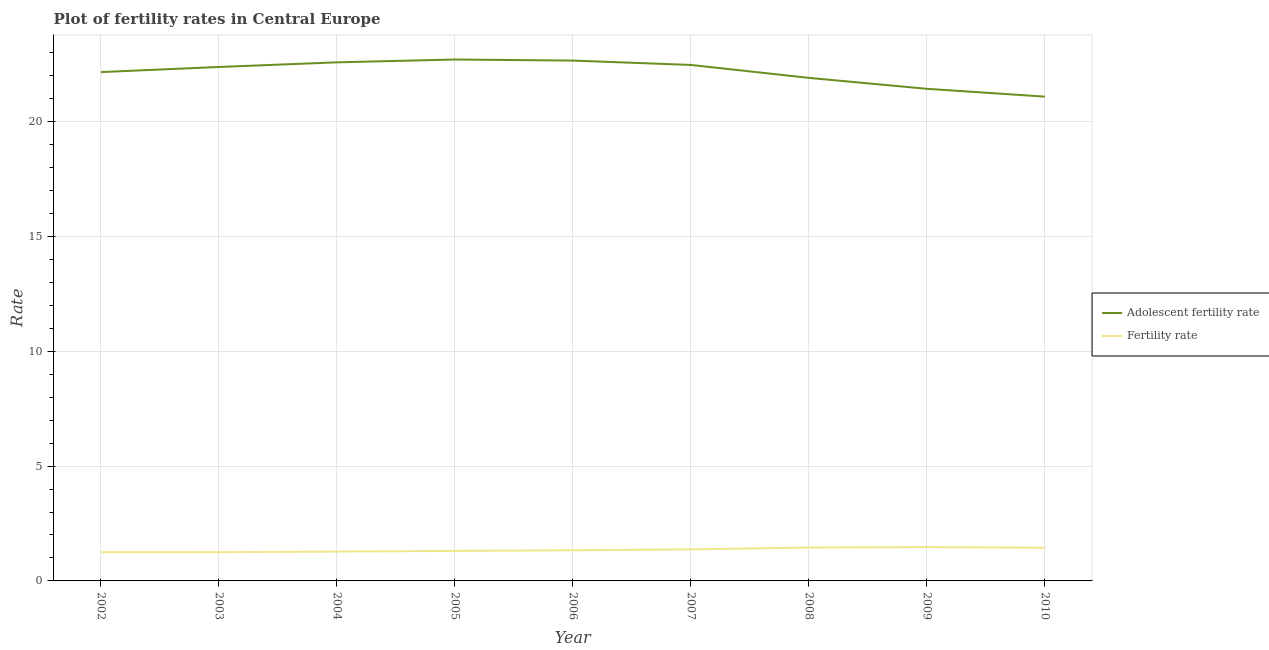How many different coloured lines are there?
Keep it short and to the point. 2. Does the line corresponding to fertility rate intersect with the line corresponding to adolescent fertility rate?
Give a very brief answer. No. What is the adolescent fertility rate in 2010?
Give a very brief answer. 21.09. Across all years, what is the maximum fertility rate?
Your answer should be very brief. 1.47. Across all years, what is the minimum fertility rate?
Provide a succinct answer. 1.25. In which year was the fertility rate maximum?
Give a very brief answer. 2009. In which year was the adolescent fertility rate minimum?
Your answer should be very brief. 2010. What is the total fertility rate in the graph?
Ensure brevity in your answer.  12.17. What is the difference between the fertility rate in 2004 and that in 2006?
Your answer should be compact. -0.06. What is the difference between the fertility rate in 2008 and the adolescent fertility rate in 2009?
Provide a short and direct response. -19.98. What is the average adolescent fertility rate per year?
Make the answer very short. 22.15. In the year 2009, what is the difference between the adolescent fertility rate and fertility rate?
Give a very brief answer. 19.96. What is the ratio of the adolescent fertility rate in 2003 to that in 2010?
Your answer should be compact. 1.06. What is the difference between the highest and the second highest adolescent fertility rate?
Your response must be concise. 0.05. What is the difference between the highest and the lowest adolescent fertility rate?
Offer a very short reply. 1.62. Is the adolescent fertility rate strictly less than the fertility rate over the years?
Keep it short and to the point. No. How many years are there in the graph?
Offer a very short reply. 9. What is the difference between two consecutive major ticks on the Y-axis?
Offer a terse response. 5. Are the values on the major ticks of Y-axis written in scientific E-notation?
Offer a very short reply. No. Does the graph contain any zero values?
Provide a succinct answer. No. Does the graph contain grids?
Your answer should be very brief. Yes. How many legend labels are there?
Your answer should be compact. 2. How are the legend labels stacked?
Provide a short and direct response. Vertical. What is the title of the graph?
Offer a terse response. Plot of fertility rates in Central Europe. What is the label or title of the X-axis?
Provide a succinct answer. Year. What is the label or title of the Y-axis?
Make the answer very short. Rate. What is the Rate of Adolescent fertility rate in 2002?
Provide a short and direct response. 22.16. What is the Rate of Fertility rate in 2002?
Your response must be concise. 1.25. What is the Rate in Adolescent fertility rate in 2003?
Provide a succinct answer. 22.38. What is the Rate in Fertility rate in 2003?
Make the answer very short. 1.25. What is the Rate in Adolescent fertility rate in 2004?
Ensure brevity in your answer.  22.58. What is the Rate of Fertility rate in 2004?
Keep it short and to the point. 1.28. What is the Rate of Adolescent fertility rate in 2005?
Keep it short and to the point. 22.7. What is the Rate of Fertility rate in 2005?
Provide a short and direct response. 1.31. What is the Rate of Adolescent fertility rate in 2006?
Your answer should be very brief. 22.66. What is the Rate of Fertility rate in 2006?
Offer a terse response. 1.33. What is the Rate of Adolescent fertility rate in 2007?
Give a very brief answer. 22.47. What is the Rate in Fertility rate in 2007?
Make the answer very short. 1.38. What is the Rate in Adolescent fertility rate in 2008?
Provide a short and direct response. 21.9. What is the Rate of Fertility rate in 2008?
Make the answer very short. 1.45. What is the Rate in Adolescent fertility rate in 2009?
Keep it short and to the point. 21.43. What is the Rate of Fertility rate in 2009?
Ensure brevity in your answer.  1.47. What is the Rate in Adolescent fertility rate in 2010?
Make the answer very short. 21.09. What is the Rate of Fertility rate in 2010?
Offer a very short reply. 1.44. Across all years, what is the maximum Rate of Adolescent fertility rate?
Offer a terse response. 22.7. Across all years, what is the maximum Rate of Fertility rate?
Provide a succinct answer. 1.47. Across all years, what is the minimum Rate of Adolescent fertility rate?
Ensure brevity in your answer.  21.09. Across all years, what is the minimum Rate in Fertility rate?
Offer a very short reply. 1.25. What is the total Rate of Adolescent fertility rate in the graph?
Make the answer very short. 199.37. What is the total Rate of Fertility rate in the graph?
Provide a short and direct response. 12.17. What is the difference between the Rate of Adolescent fertility rate in 2002 and that in 2003?
Your answer should be very brief. -0.22. What is the difference between the Rate in Fertility rate in 2002 and that in 2003?
Your answer should be very brief. 0. What is the difference between the Rate in Adolescent fertility rate in 2002 and that in 2004?
Give a very brief answer. -0.42. What is the difference between the Rate in Fertility rate in 2002 and that in 2004?
Offer a terse response. -0.03. What is the difference between the Rate in Adolescent fertility rate in 2002 and that in 2005?
Provide a short and direct response. -0.55. What is the difference between the Rate in Fertility rate in 2002 and that in 2005?
Give a very brief answer. -0.06. What is the difference between the Rate of Adolescent fertility rate in 2002 and that in 2006?
Your response must be concise. -0.5. What is the difference between the Rate in Fertility rate in 2002 and that in 2006?
Make the answer very short. -0.08. What is the difference between the Rate in Adolescent fertility rate in 2002 and that in 2007?
Provide a short and direct response. -0.31. What is the difference between the Rate of Fertility rate in 2002 and that in 2007?
Give a very brief answer. -0.12. What is the difference between the Rate of Adolescent fertility rate in 2002 and that in 2008?
Your response must be concise. 0.25. What is the difference between the Rate in Fertility rate in 2002 and that in 2008?
Your response must be concise. -0.2. What is the difference between the Rate of Adolescent fertility rate in 2002 and that in 2009?
Provide a short and direct response. 0.73. What is the difference between the Rate of Fertility rate in 2002 and that in 2009?
Provide a succinct answer. -0.22. What is the difference between the Rate in Adolescent fertility rate in 2002 and that in 2010?
Give a very brief answer. 1.07. What is the difference between the Rate of Fertility rate in 2002 and that in 2010?
Provide a short and direct response. -0.19. What is the difference between the Rate of Adolescent fertility rate in 2003 and that in 2004?
Offer a very short reply. -0.2. What is the difference between the Rate of Fertility rate in 2003 and that in 2004?
Provide a succinct answer. -0.03. What is the difference between the Rate of Adolescent fertility rate in 2003 and that in 2005?
Your response must be concise. -0.32. What is the difference between the Rate in Fertility rate in 2003 and that in 2005?
Make the answer very short. -0.06. What is the difference between the Rate in Adolescent fertility rate in 2003 and that in 2006?
Provide a short and direct response. -0.28. What is the difference between the Rate in Fertility rate in 2003 and that in 2006?
Ensure brevity in your answer.  -0.08. What is the difference between the Rate in Adolescent fertility rate in 2003 and that in 2007?
Your answer should be compact. -0.09. What is the difference between the Rate in Fertility rate in 2003 and that in 2007?
Provide a succinct answer. -0.12. What is the difference between the Rate of Adolescent fertility rate in 2003 and that in 2008?
Your answer should be compact. 0.48. What is the difference between the Rate of Fertility rate in 2003 and that in 2008?
Keep it short and to the point. -0.2. What is the difference between the Rate of Adolescent fertility rate in 2003 and that in 2009?
Provide a succinct answer. 0.95. What is the difference between the Rate of Fertility rate in 2003 and that in 2009?
Your answer should be compact. -0.22. What is the difference between the Rate of Adolescent fertility rate in 2003 and that in 2010?
Provide a succinct answer. 1.29. What is the difference between the Rate of Fertility rate in 2003 and that in 2010?
Make the answer very short. -0.19. What is the difference between the Rate in Adolescent fertility rate in 2004 and that in 2005?
Your response must be concise. -0.12. What is the difference between the Rate in Fertility rate in 2004 and that in 2005?
Provide a short and direct response. -0.03. What is the difference between the Rate in Adolescent fertility rate in 2004 and that in 2006?
Offer a very short reply. -0.08. What is the difference between the Rate of Fertility rate in 2004 and that in 2006?
Provide a short and direct response. -0.06. What is the difference between the Rate of Adolescent fertility rate in 2004 and that in 2007?
Provide a succinct answer. 0.11. What is the difference between the Rate in Fertility rate in 2004 and that in 2007?
Ensure brevity in your answer.  -0.1. What is the difference between the Rate of Adolescent fertility rate in 2004 and that in 2008?
Give a very brief answer. 0.68. What is the difference between the Rate in Fertility rate in 2004 and that in 2008?
Your answer should be compact. -0.17. What is the difference between the Rate of Adolescent fertility rate in 2004 and that in 2009?
Your answer should be very brief. 1.15. What is the difference between the Rate of Fertility rate in 2004 and that in 2009?
Your answer should be very brief. -0.2. What is the difference between the Rate in Adolescent fertility rate in 2004 and that in 2010?
Offer a terse response. 1.49. What is the difference between the Rate of Fertility rate in 2004 and that in 2010?
Keep it short and to the point. -0.17. What is the difference between the Rate in Adolescent fertility rate in 2005 and that in 2006?
Offer a terse response. 0.05. What is the difference between the Rate in Fertility rate in 2005 and that in 2006?
Ensure brevity in your answer.  -0.03. What is the difference between the Rate of Adolescent fertility rate in 2005 and that in 2007?
Provide a short and direct response. 0.24. What is the difference between the Rate in Fertility rate in 2005 and that in 2007?
Give a very brief answer. -0.07. What is the difference between the Rate of Adolescent fertility rate in 2005 and that in 2008?
Your answer should be compact. 0.8. What is the difference between the Rate of Fertility rate in 2005 and that in 2008?
Your answer should be very brief. -0.15. What is the difference between the Rate of Adolescent fertility rate in 2005 and that in 2009?
Your answer should be compact. 1.28. What is the difference between the Rate of Fertility rate in 2005 and that in 2009?
Offer a very short reply. -0.17. What is the difference between the Rate in Adolescent fertility rate in 2005 and that in 2010?
Your answer should be compact. 1.62. What is the difference between the Rate in Fertility rate in 2005 and that in 2010?
Provide a short and direct response. -0.14. What is the difference between the Rate of Adolescent fertility rate in 2006 and that in 2007?
Offer a very short reply. 0.19. What is the difference between the Rate of Fertility rate in 2006 and that in 2007?
Your response must be concise. -0.04. What is the difference between the Rate in Adolescent fertility rate in 2006 and that in 2008?
Your answer should be very brief. 0.75. What is the difference between the Rate of Fertility rate in 2006 and that in 2008?
Provide a short and direct response. -0.12. What is the difference between the Rate in Adolescent fertility rate in 2006 and that in 2009?
Offer a very short reply. 1.23. What is the difference between the Rate of Fertility rate in 2006 and that in 2009?
Make the answer very short. -0.14. What is the difference between the Rate of Adolescent fertility rate in 2006 and that in 2010?
Offer a terse response. 1.57. What is the difference between the Rate in Fertility rate in 2006 and that in 2010?
Make the answer very short. -0.11. What is the difference between the Rate of Adolescent fertility rate in 2007 and that in 2008?
Provide a short and direct response. 0.56. What is the difference between the Rate of Fertility rate in 2007 and that in 2008?
Your answer should be very brief. -0.08. What is the difference between the Rate of Adolescent fertility rate in 2007 and that in 2009?
Your response must be concise. 1.04. What is the difference between the Rate in Fertility rate in 2007 and that in 2009?
Your answer should be very brief. -0.1. What is the difference between the Rate in Adolescent fertility rate in 2007 and that in 2010?
Make the answer very short. 1.38. What is the difference between the Rate in Fertility rate in 2007 and that in 2010?
Ensure brevity in your answer.  -0.07. What is the difference between the Rate in Adolescent fertility rate in 2008 and that in 2009?
Your answer should be very brief. 0.48. What is the difference between the Rate in Fertility rate in 2008 and that in 2009?
Offer a terse response. -0.02. What is the difference between the Rate of Adolescent fertility rate in 2008 and that in 2010?
Provide a succinct answer. 0.82. What is the difference between the Rate of Fertility rate in 2008 and that in 2010?
Your answer should be compact. 0.01. What is the difference between the Rate in Adolescent fertility rate in 2009 and that in 2010?
Provide a succinct answer. 0.34. What is the difference between the Rate in Fertility rate in 2009 and that in 2010?
Your answer should be very brief. 0.03. What is the difference between the Rate of Adolescent fertility rate in 2002 and the Rate of Fertility rate in 2003?
Offer a terse response. 20.91. What is the difference between the Rate of Adolescent fertility rate in 2002 and the Rate of Fertility rate in 2004?
Make the answer very short. 20.88. What is the difference between the Rate in Adolescent fertility rate in 2002 and the Rate in Fertility rate in 2005?
Your response must be concise. 20.85. What is the difference between the Rate in Adolescent fertility rate in 2002 and the Rate in Fertility rate in 2006?
Keep it short and to the point. 20.82. What is the difference between the Rate in Adolescent fertility rate in 2002 and the Rate in Fertility rate in 2007?
Your answer should be very brief. 20.78. What is the difference between the Rate of Adolescent fertility rate in 2002 and the Rate of Fertility rate in 2008?
Ensure brevity in your answer.  20.7. What is the difference between the Rate of Adolescent fertility rate in 2002 and the Rate of Fertility rate in 2009?
Your response must be concise. 20.68. What is the difference between the Rate in Adolescent fertility rate in 2002 and the Rate in Fertility rate in 2010?
Your answer should be compact. 20.71. What is the difference between the Rate of Adolescent fertility rate in 2003 and the Rate of Fertility rate in 2004?
Make the answer very short. 21.1. What is the difference between the Rate in Adolescent fertility rate in 2003 and the Rate in Fertility rate in 2005?
Make the answer very short. 21.07. What is the difference between the Rate of Adolescent fertility rate in 2003 and the Rate of Fertility rate in 2006?
Your answer should be very brief. 21.05. What is the difference between the Rate in Adolescent fertility rate in 2003 and the Rate in Fertility rate in 2007?
Provide a short and direct response. 21. What is the difference between the Rate of Adolescent fertility rate in 2003 and the Rate of Fertility rate in 2008?
Your answer should be compact. 20.93. What is the difference between the Rate in Adolescent fertility rate in 2003 and the Rate in Fertility rate in 2009?
Your response must be concise. 20.91. What is the difference between the Rate in Adolescent fertility rate in 2003 and the Rate in Fertility rate in 2010?
Your answer should be compact. 20.94. What is the difference between the Rate of Adolescent fertility rate in 2004 and the Rate of Fertility rate in 2005?
Provide a succinct answer. 21.27. What is the difference between the Rate of Adolescent fertility rate in 2004 and the Rate of Fertility rate in 2006?
Offer a terse response. 21.25. What is the difference between the Rate of Adolescent fertility rate in 2004 and the Rate of Fertility rate in 2007?
Provide a short and direct response. 21.21. What is the difference between the Rate in Adolescent fertility rate in 2004 and the Rate in Fertility rate in 2008?
Offer a very short reply. 21.13. What is the difference between the Rate of Adolescent fertility rate in 2004 and the Rate of Fertility rate in 2009?
Make the answer very short. 21.11. What is the difference between the Rate in Adolescent fertility rate in 2004 and the Rate in Fertility rate in 2010?
Offer a very short reply. 21.14. What is the difference between the Rate of Adolescent fertility rate in 2005 and the Rate of Fertility rate in 2006?
Give a very brief answer. 21.37. What is the difference between the Rate of Adolescent fertility rate in 2005 and the Rate of Fertility rate in 2007?
Keep it short and to the point. 21.33. What is the difference between the Rate of Adolescent fertility rate in 2005 and the Rate of Fertility rate in 2008?
Provide a short and direct response. 21.25. What is the difference between the Rate in Adolescent fertility rate in 2005 and the Rate in Fertility rate in 2009?
Your answer should be compact. 21.23. What is the difference between the Rate of Adolescent fertility rate in 2005 and the Rate of Fertility rate in 2010?
Your answer should be compact. 21.26. What is the difference between the Rate of Adolescent fertility rate in 2006 and the Rate of Fertility rate in 2007?
Give a very brief answer. 21.28. What is the difference between the Rate of Adolescent fertility rate in 2006 and the Rate of Fertility rate in 2008?
Make the answer very short. 21.21. What is the difference between the Rate in Adolescent fertility rate in 2006 and the Rate in Fertility rate in 2009?
Ensure brevity in your answer.  21.18. What is the difference between the Rate in Adolescent fertility rate in 2006 and the Rate in Fertility rate in 2010?
Your answer should be very brief. 21.21. What is the difference between the Rate in Adolescent fertility rate in 2007 and the Rate in Fertility rate in 2008?
Give a very brief answer. 21.02. What is the difference between the Rate in Adolescent fertility rate in 2007 and the Rate in Fertility rate in 2009?
Offer a very short reply. 21. What is the difference between the Rate in Adolescent fertility rate in 2007 and the Rate in Fertility rate in 2010?
Provide a succinct answer. 21.02. What is the difference between the Rate in Adolescent fertility rate in 2008 and the Rate in Fertility rate in 2009?
Keep it short and to the point. 20.43. What is the difference between the Rate in Adolescent fertility rate in 2008 and the Rate in Fertility rate in 2010?
Give a very brief answer. 20.46. What is the difference between the Rate of Adolescent fertility rate in 2009 and the Rate of Fertility rate in 2010?
Provide a succinct answer. 19.98. What is the average Rate in Adolescent fertility rate per year?
Offer a very short reply. 22.15. What is the average Rate of Fertility rate per year?
Give a very brief answer. 1.35. In the year 2002, what is the difference between the Rate in Adolescent fertility rate and Rate in Fertility rate?
Provide a succinct answer. 20.9. In the year 2003, what is the difference between the Rate in Adolescent fertility rate and Rate in Fertility rate?
Offer a terse response. 21.13. In the year 2004, what is the difference between the Rate in Adolescent fertility rate and Rate in Fertility rate?
Provide a succinct answer. 21.3. In the year 2005, what is the difference between the Rate in Adolescent fertility rate and Rate in Fertility rate?
Ensure brevity in your answer.  21.4. In the year 2006, what is the difference between the Rate of Adolescent fertility rate and Rate of Fertility rate?
Your answer should be compact. 21.32. In the year 2007, what is the difference between the Rate of Adolescent fertility rate and Rate of Fertility rate?
Your answer should be compact. 21.09. In the year 2008, what is the difference between the Rate in Adolescent fertility rate and Rate in Fertility rate?
Keep it short and to the point. 20.45. In the year 2009, what is the difference between the Rate in Adolescent fertility rate and Rate in Fertility rate?
Your answer should be very brief. 19.96. In the year 2010, what is the difference between the Rate of Adolescent fertility rate and Rate of Fertility rate?
Your answer should be very brief. 19.64. What is the ratio of the Rate of Adolescent fertility rate in 2002 to that in 2003?
Your response must be concise. 0.99. What is the ratio of the Rate in Adolescent fertility rate in 2002 to that in 2004?
Offer a terse response. 0.98. What is the ratio of the Rate in Fertility rate in 2002 to that in 2004?
Ensure brevity in your answer.  0.98. What is the ratio of the Rate in Adolescent fertility rate in 2002 to that in 2005?
Your answer should be compact. 0.98. What is the ratio of the Rate in Fertility rate in 2002 to that in 2005?
Provide a short and direct response. 0.96. What is the ratio of the Rate of Adolescent fertility rate in 2002 to that in 2006?
Keep it short and to the point. 0.98. What is the ratio of the Rate of Fertility rate in 2002 to that in 2006?
Make the answer very short. 0.94. What is the ratio of the Rate in Adolescent fertility rate in 2002 to that in 2007?
Provide a short and direct response. 0.99. What is the ratio of the Rate in Fertility rate in 2002 to that in 2007?
Give a very brief answer. 0.91. What is the ratio of the Rate of Adolescent fertility rate in 2002 to that in 2008?
Offer a very short reply. 1.01. What is the ratio of the Rate in Fertility rate in 2002 to that in 2008?
Your answer should be compact. 0.86. What is the ratio of the Rate of Adolescent fertility rate in 2002 to that in 2009?
Your answer should be compact. 1.03. What is the ratio of the Rate in Adolescent fertility rate in 2002 to that in 2010?
Ensure brevity in your answer.  1.05. What is the ratio of the Rate of Fertility rate in 2002 to that in 2010?
Give a very brief answer. 0.87. What is the ratio of the Rate of Fertility rate in 2003 to that in 2004?
Your response must be concise. 0.98. What is the ratio of the Rate in Adolescent fertility rate in 2003 to that in 2005?
Keep it short and to the point. 0.99. What is the ratio of the Rate of Fertility rate in 2003 to that in 2005?
Your answer should be very brief. 0.96. What is the ratio of the Rate in Adolescent fertility rate in 2003 to that in 2006?
Provide a succinct answer. 0.99. What is the ratio of the Rate in Fertility rate in 2003 to that in 2006?
Ensure brevity in your answer.  0.94. What is the ratio of the Rate in Fertility rate in 2003 to that in 2007?
Keep it short and to the point. 0.91. What is the ratio of the Rate of Adolescent fertility rate in 2003 to that in 2008?
Your response must be concise. 1.02. What is the ratio of the Rate of Fertility rate in 2003 to that in 2008?
Give a very brief answer. 0.86. What is the ratio of the Rate in Adolescent fertility rate in 2003 to that in 2009?
Your response must be concise. 1.04. What is the ratio of the Rate in Fertility rate in 2003 to that in 2009?
Ensure brevity in your answer.  0.85. What is the ratio of the Rate in Adolescent fertility rate in 2003 to that in 2010?
Ensure brevity in your answer.  1.06. What is the ratio of the Rate in Fertility rate in 2003 to that in 2010?
Offer a very short reply. 0.87. What is the ratio of the Rate in Adolescent fertility rate in 2004 to that in 2005?
Provide a succinct answer. 0.99. What is the ratio of the Rate of Fertility rate in 2004 to that in 2005?
Your response must be concise. 0.98. What is the ratio of the Rate of Fertility rate in 2004 to that in 2006?
Offer a terse response. 0.96. What is the ratio of the Rate in Adolescent fertility rate in 2004 to that in 2007?
Your answer should be compact. 1. What is the ratio of the Rate in Fertility rate in 2004 to that in 2007?
Keep it short and to the point. 0.93. What is the ratio of the Rate of Adolescent fertility rate in 2004 to that in 2008?
Provide a succinct answer. 1.03. What is the ratio of the Rate in Fertility rate in 2004 to that in 2008?
Keep it short and to the point. 0.88. What is the ratio of the Rate of Adolescent fertility rate in 2004 to that in 2009?
Offer a very short reply. 1.05. What is the ratio of the Rate in Fertility rate in 2004 to that in 2009?
Provide a short and direct response. 0.87. What is the ratio of the Rate of Adolescent fertility rate in 2004 to that in 2010?
Offer a very short reply. 1.07. What is the ratio of the Rate of Fertility rate in 2004 to that in 2010?
Make the answer very short. 0.88. What is the ratio of the Rate of Fertility rate in 2005 to that in 2006?
Offer a very short reply. 0.98. What is the ratio of the Rate in Adolescent fertility rate in 2005 to that in 2007?
Keep it short and to the point. 1.01. What is the ratio of the Rate of Fertility rate in 2005 to that in 2007?
Offer a terse response. 0.95. What is the ratio of the Rate of Adolescent fertility rate in 2005 to that in 2008?
Give a very brief answer. 1.04. What is the ratio of the Rate in Fertility rate in 2005 to that in 2008?
Offer a terse response. 0.9. What is the ratio of the Rate of Adolescent fertility rate in 2005 to that in 2009?
Offer a very short reply. 1.06. What is the ratio of the Rate of Fertility rate in 2005 to that in 2009?
Provide a succinct answer. 0.89. What is the ratio of the Rate of Adolescent fertility rate in 2005 to that in 2010?
Your response must be concise. 1.08. What is the ratio of the Rate in Fertility rate in 2005 to that in 2010?
Provide a short and direct response. 0.91. What is the ratio of the Rate of Adolescent fertility rate in 2006 to that in 2007?
Keep it short and to the point. 1.01. What is the ratio of the Rate in Fertility rate in 2006 to that in 2007?
Offer a very short reply. 0.97. What is the ratio of the Rate in Adolescent fertility rate in 2006 to that in 2008?
Ensure brevity in your answer.  1.03. What is the ratio of the Rate of Fertility rate in 2006 to that in 2008?
Provide a succinct answer. 0.92. What is the ratio of the Rate in Adolescent fertility rate in 2006 to that in 2009?
Your answer should be compact. 1.06. What is the ratio of the Rate in Fertility rate in 2006 to that in 2009?
Ensure brevity in your answer.  0.91. What is the ratio of the Rate of Adolescent fertility rate in 2006 to that in 2010?
Provide a succinct answer. 1.07. What is the ratio of the Rate in Fertility rate in 2006 to that in 2010?
Offer a very short reply. 0.92. What is the ratio of the Rate of Adolescent fertility rate in 2007 to that in 2008?
Offer a very short reply. 1.03. What is the ratio of the Rate of Fertility rate in 2007 to that in 2008?
Offer a very short reply. 0.95. What is the ratio of the Rate in Adolescent fertility rate in 2007 to that in 2009?
Give a very brief answer. 1.05. What is the ratio of the Rate in Fertility rate in 2007 to that in 2009?
Give a very brief answer. 0.93. What is the ratio of the Rate in Adolescent fertility rate in 2007 to that in 2010?
Keep it short and to the point. 1.07. What is the ratio of the Rate in Fertility rate in 2007 to that in 2010?
Your answer should be compact. 0.95. What is the ratio of the Rate in Adolescent fertility rate in 2008 to that in 2009?
Your answer should be compact. 1.02. What is the ratio of the Rate in Fertility rate in 2008 to that in 2009?
Offer a very short reply. 0.99. What is the ratio of the Rate of Adolescent fertility rate in 2008 to that in 2010?
Make the answer very short. 1.04. What is the ratio of the Rate of Adolescent fertility rate in 2009 to that in 2010?
Give a very brief answer. 1.02. What is the ratio of the Rate of Fertility rate in 2009 to that in 2010?
Your answer should be very brief. 1.02. What is the difference between the highest and the second highest Rate of Adolescent fertility rate?
Your response must be concise. 0.05. What is the difference between the highest and the second highest Rate of Fertility rate?
Your answer should be compact. 0.02. What is the difference between the highest and the lowest Rate in Adolescent fertility rate?
Give a very brief answer. 1.62. What is the difference between the highest and the lowest Rate in Fertility rate?
Give a very brief answer. 0.22. 